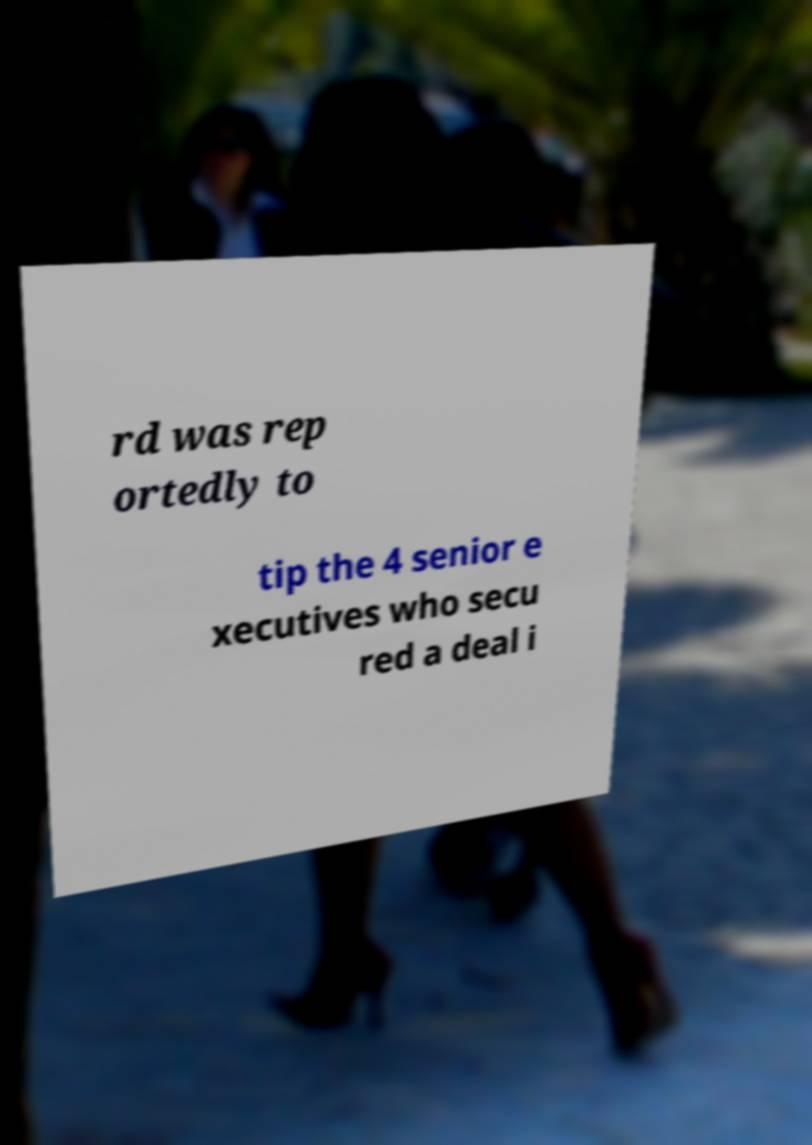There's text embedded in this image that I need extracted. Can you transcribe it verbatim? rd was rep ortedly to tip the 4 senior e xecutives who secu red a deal i 